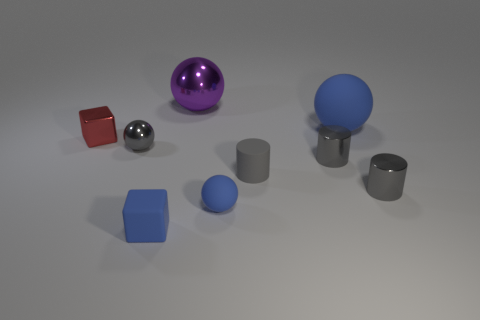Do the red object and the rubber thing that is on the left side of the large purple shiny thing have the same shape?
Your response must be concise. Yes. How many rubber objects are tiny gray cylinders or gray balls?
Offer a terse response. 1. What color is the tiny cube in front of the small sphere that is left of the blue sphere in front of the large blue object?
Give a very brief answer. Blue. What number of other objects are the same material as the large blue object?
Offer a very short reply. 3. There is a small blue object to the left of the purple metallic thing; does it have the same shape as the red shiny object?
Provide a succinct answer. Yes. What number of large things are metal cylinders or blue rubber things?
Your answer should be compact. 1. Are there an equal number of small spheres on the left side of the red object and blue rubber balls that are on the left side of the small metal ball?
Your response must be concise. Yes. How many other things are there of the same color as the metal cube?
Give a very brief answer. 0. Is the color of the large matte thing the same as the matte thing that is to the left of the purple shiny object?
Your answer should be compact. Yes. What number of blue things are large things or large shiny spheres?
Your answer should be very brief. 1. 